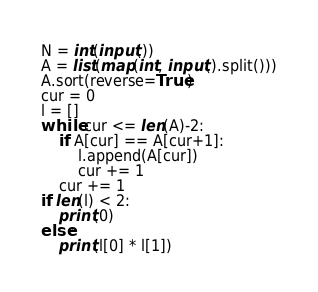Convert code to text. <code><loc_0><loc_0><loc_500><loc_500><_Python_>N = int(input())
A = list(map(int, input().split()))
A.sort(reverse=True)
cur = 0
l = []
while cur <= len(A)-2:
    if A[cur] == A[cur+1]:
        l.append(A[cur])
        cur += 1
    cur += 1
if len(l) < 2:
    print(0)
else:
    print(l[0] * l[1])</code> 